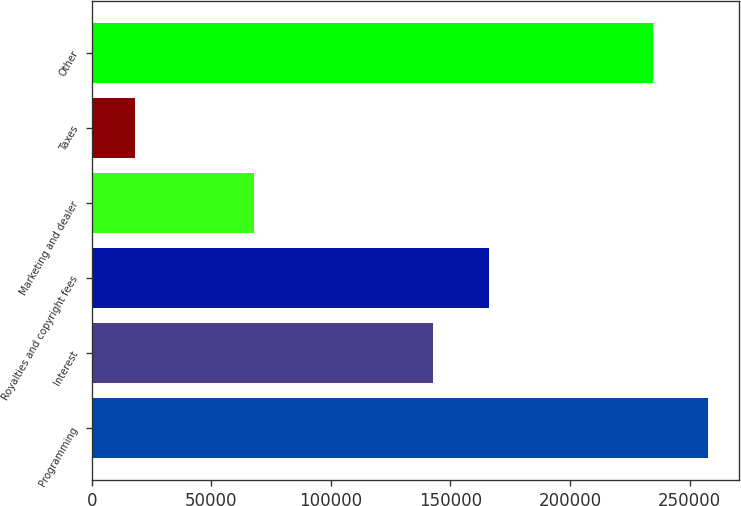Convert chart to OTSL. <chart><loc_0><loc_0><loc_500><loc_500><bar_chart><fcel>Programming<fcel>Interest<fcel>Royalties and copyright fees<fcel>Marketing and dealer<fcel>Taxes<fcel>Other<nl><fcel>257926<fcel>142789<fcel>166075<fcel>67996<fcel>17933<fcel>234640<nl></chart> 